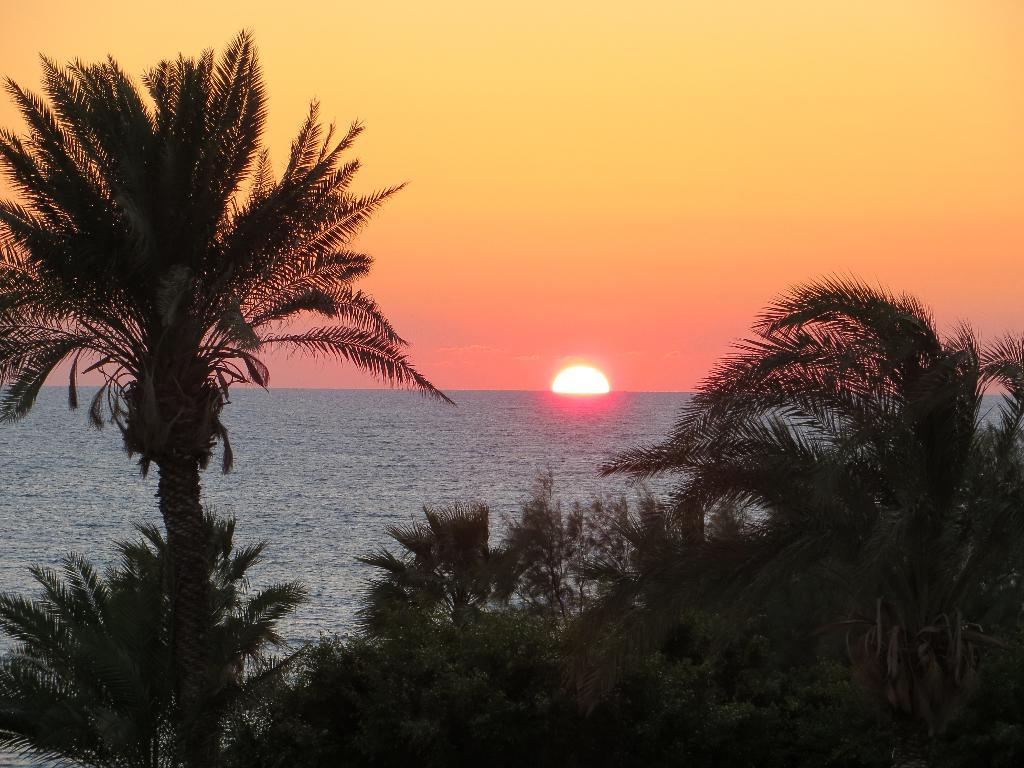What time of day is depicted in the image? The image is taken during sunset. What type of vegetation can be seen at the bottom of the image? There are trees at the bottom of the image. What is in the middle of the image? There is water in the middle of the image. What is visible at the top of the image? The sky is visible at the top of the image. What celestial body is present in the sky? The sun is present in the sky. What type of motion can be seen in the water in the image? There is no motion visible in the water in the image; it appears to be still. What is the servant's role in the image? There is no servant present in the image. 